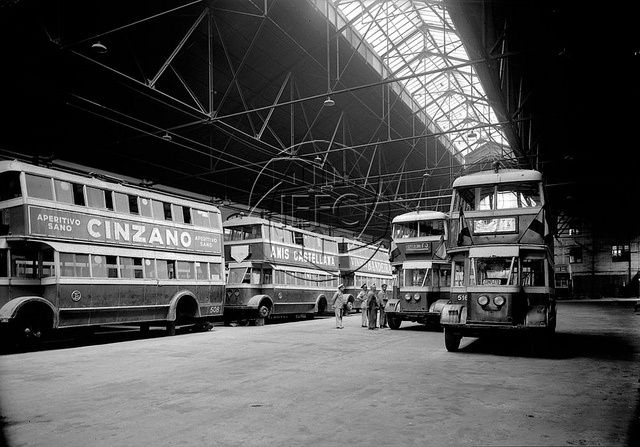Describe the objects in this image and their specific colors. I can see bus in black, darkgray, gray, and lightgray tones, bus in black, gray, darkgray, and lightgray tones, bus in black, darkgray, gray, and lightgray tones, bus in black, gray, darkgray, and lightgray tones, and people in black, darkgray, gray, and lightgray tones in this image. 